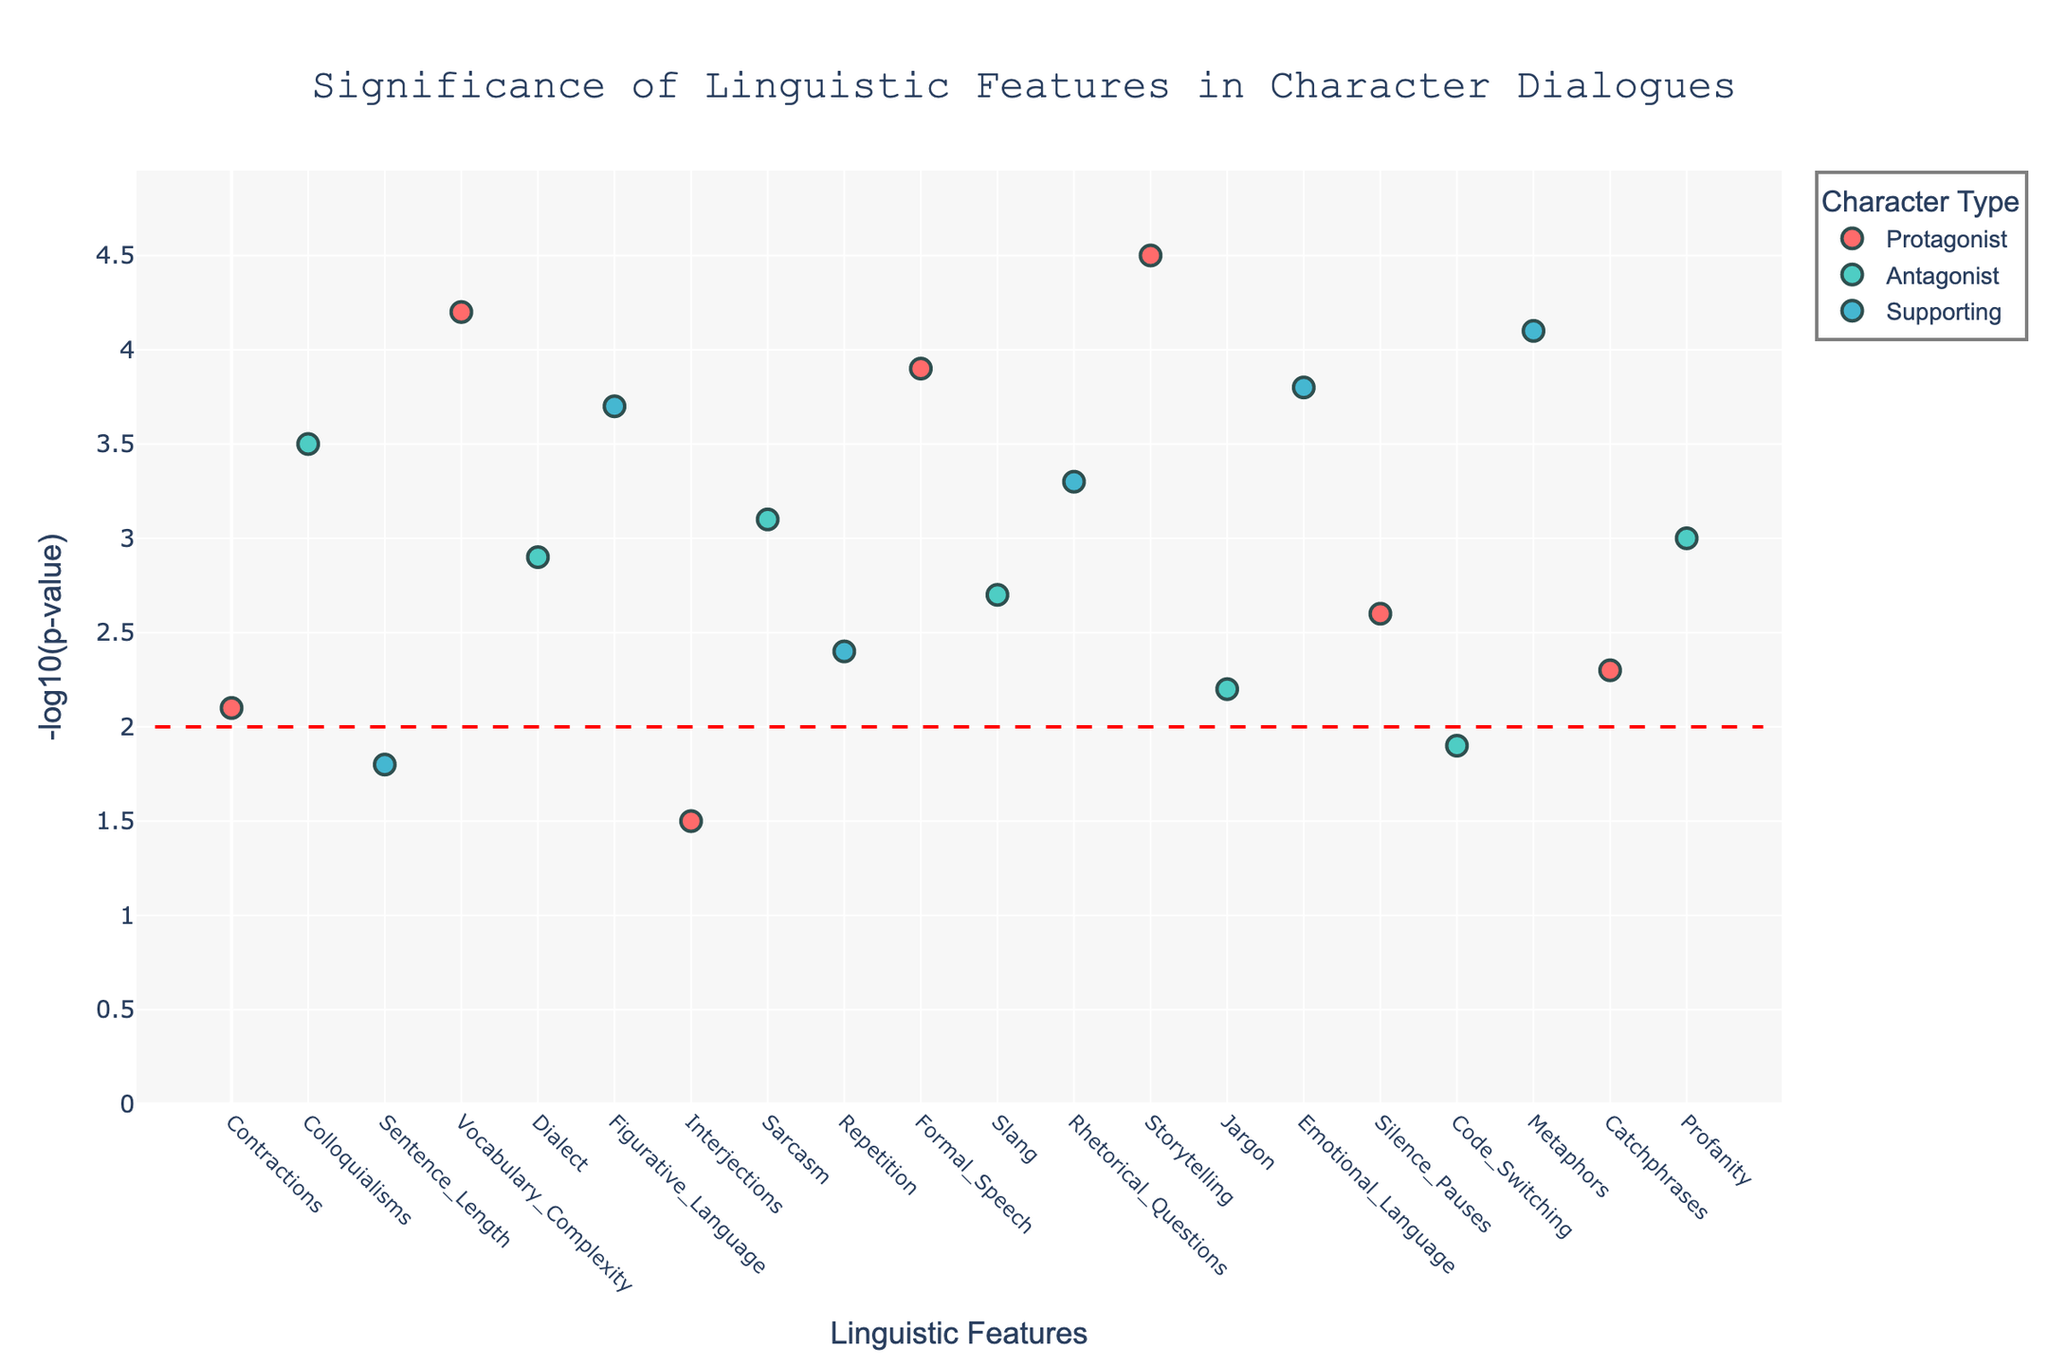What is the title of the plot? The title is displayed at the top of the plot in a large, bold font, providing an overview of what the plot represents.
Answer: Significance of Linguistic Features in Character Dialogues How many different character types are represented in the plot? To determine the number of character types, look at the legend, which shows the distinct categories indicated by different colors.
Answer: 3 Which linguistic feature has the highest significance for Protagonists? Identify the linguistic features associated with Protagonists (in red) and find the highest point on the y-axis representing the -log10(p-value).
Answer: Storytelling What is the significance threshold indicated in the plot? The significance threshold is indicated by a horizontal red dashed line, which is labeled or positioned on the y-axis.
Answer: 2 Between Protagonists and Antagonists, which group has more linguistic features above the significance threshold? Count the data points above the horizontal red dashed line for both Protagonists and Antagonists and compare the totals.
Answer: Protagonists Which linguistic feature associated with Supporting characters has the highest significance? Look at the data points for Supporting characters (in blue) and find the one with the highest -log10(p-value) on the y-axis.
Answer: Metaphors Which character type has the least significant (lowest -log10(p-value)) linguistic feature, and what is that feature? Find the data point with the lowest -log10(p-value) across all character types and identify its corresponding feature and character type.
Answer: Protagonists, Interjections What is the -log10(p-value) of Profanity for Antagonists? Locate the data point labeled "Profanity" for Antagonists (in green) and read off its corresponding -log10(p-value) on the y-axis.
Answer: 3.0 Is there any linguistic feature related to Protagonists that doesn't meet the significance threshold? Check the data points for Protagonists (in red) and see if any of them fall below the horizontal red dashed line indicating the significance threshold.
Answer: Yes What is the combined significance (-log10(p-value)) of Figurative Language, Rhetorical Questions, and Emotional Language for Supporting characters? Sum the -log10(p-value) for these three linguistic features associated with Supporting characters (Figurative Language: 3.7, Rhetorical Questions: 3.3, Emotional Language: 3.8). 3.7 + 3.3 + 3.8 = 10.8
Answer: 10.8 